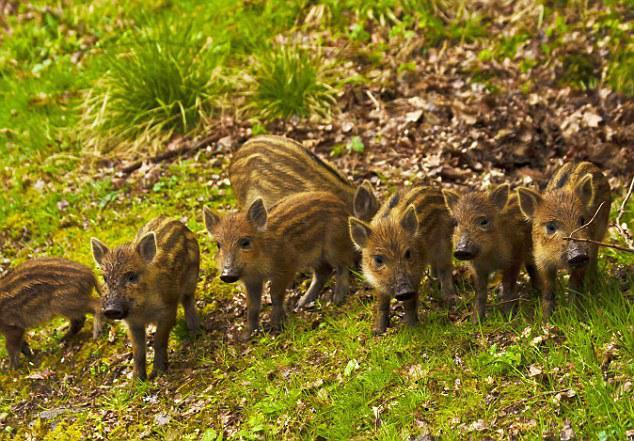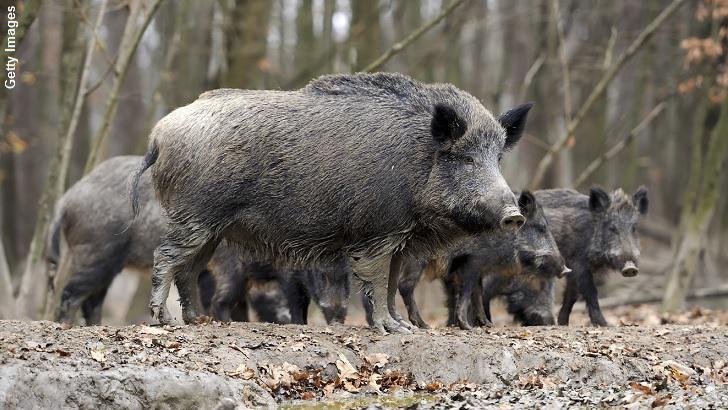The first image is the image on the left, the second image is the image on the right. For the images shown, is this caption "One image contains only baby piglets with distinctive brown and beige striped fur, standing on ground with bright green grass." true? Answer yes or no. Yes. The first image is the image on the left, the second image is the image on the right. Evaluate the accuracy of this statement regarding the images: "In one image, a boar is standing in snow.". Is it true? Answer yes or no. No. 